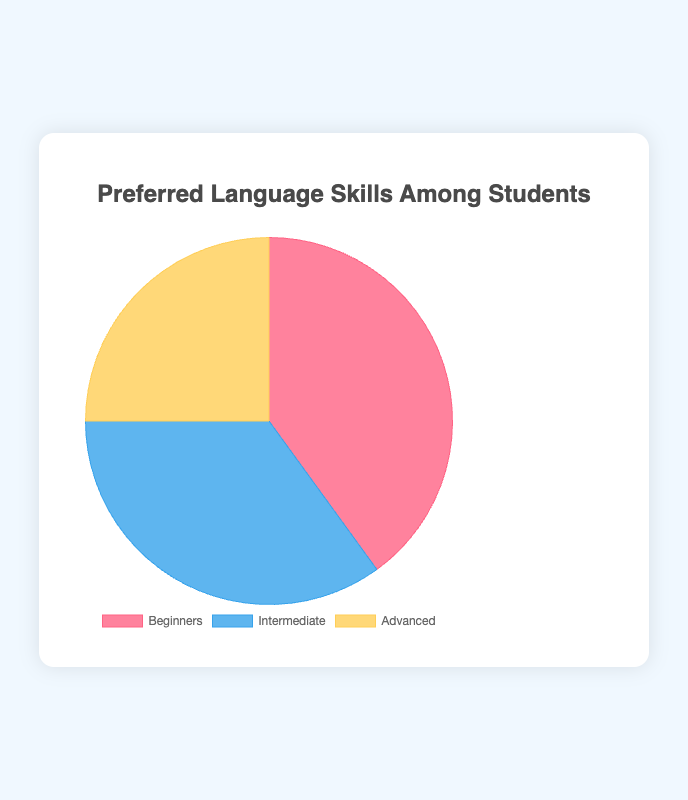What is the percentage of students at the Beginners level? From the pie chart, it shows that the portion labeled as "Beginners" represents 40% of the total students.
Answer: 40% Which level has the smallest percentage of students? Among the levels shown in the pie chart, the "Advanced" level has the smallest segment, indicating it has the lowest percentage at 25%.
Answer: Advanced How much higher is the percentage of Beginners compared to Advanced? The pie chart shows that Beginners are at 40% and Advanced are at 25%. The difference is 40% - 25% = 15%.
Answer: 15% What is the total percentage of students in the Beginners and Intermediate levels combined? The Beginners level is 40% and the Intermediate level is 35%. Adding them together gives 40% + 35% = 75%.
Answer: 75% Which level has more students, Intermediate or Advanced, and by what percentage? The Intermediate level has 35% and the Advanced level has 25%. The Intermediate level has 35% - 25% = 10% more students than the Advanced level.
Answer: Intermediate; 10% What color represents the Intermediate level in the pie chart? Visually, the segment corresponding to the Intermediate level is depicted in blue.
Answer: Blue By what factor is the percentage of Beginners greater than the percentage of Advanced? The percentage of Beginners is 40%, and the percentage of Advanced is 25%. The factor is calculated by dividing 40% by 25%, which gives 40 / 25 = 1.6.
Answer: 1.6 If the total number of students is 200, how many students are at the Intermediate level? The Intermediate level represents 35% of the total students. Therefore, the number of Intermediate students is 35% of 200, calculated as (35/100) * 200 = 70 students.
Answer: 70 What is the average percentage of students across all three levels? The percentages of the three levels are 40%, 35%, and 25%. Adding them together gives 40 + 35 + 25 = 100. Dividing this total by 3 levels, the average percentage is 100 / 3 ≈ 33.33%.
Answer: 33.33% 